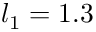<formula> <loc_0><loc_0><loc_500><loc_500>l _ { 1 } = 1 . 3</formula> 